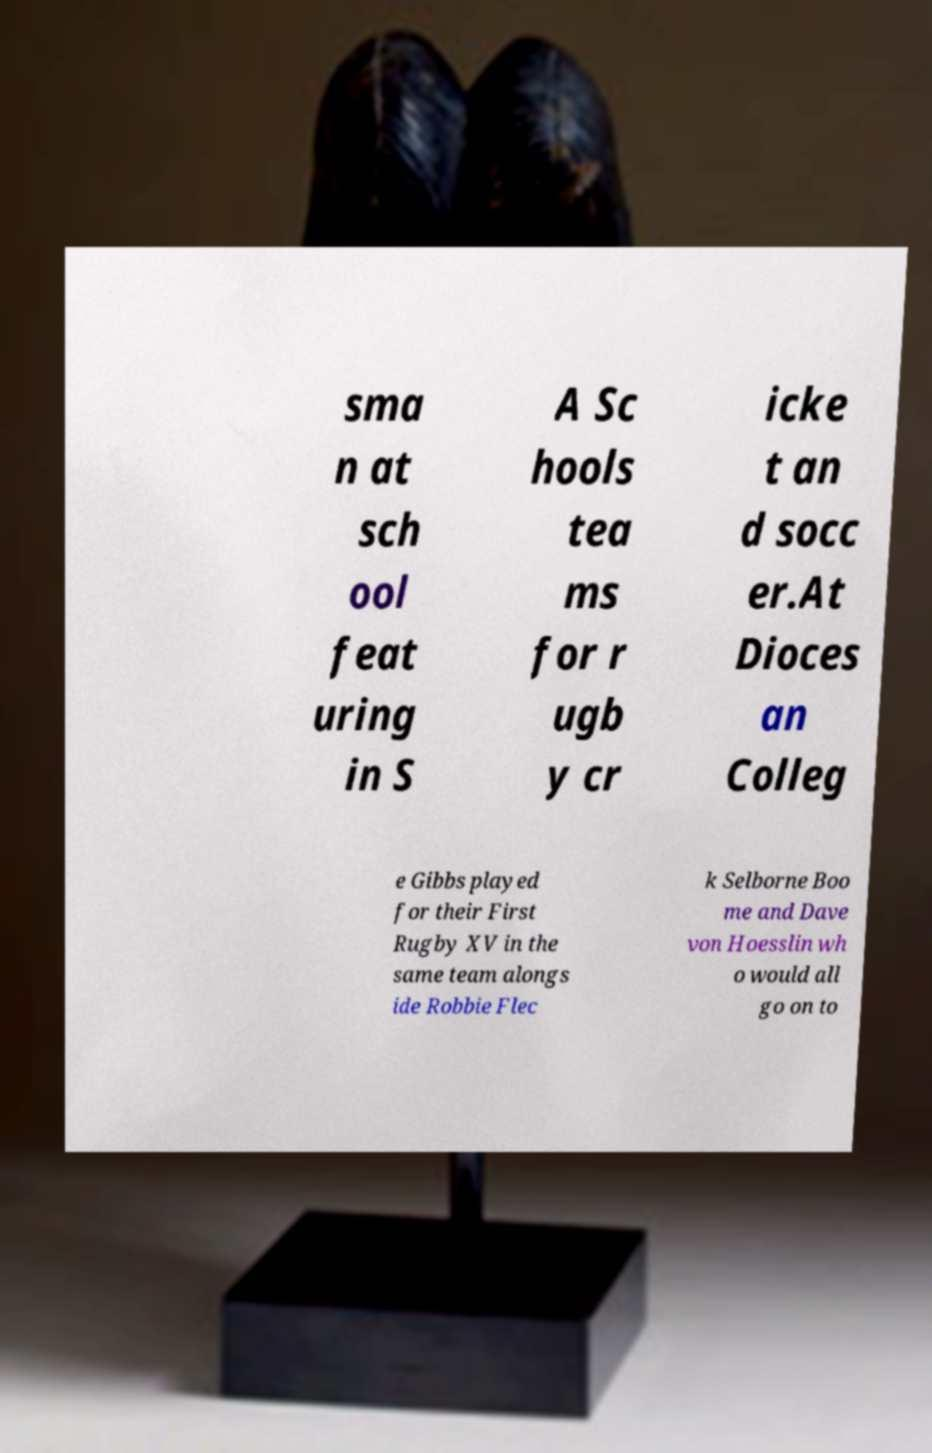Could you assist in decoding the text presented in this image and type it out clearly? sma n at sch ool feat uring in S A Sc hools tea ms for r ugb y cr icke t an d socc er.At Dioces an Colleg e Gibbs played for their First Rugby XV in the same team alongs ide Robbie Flec k Selborne Boo me and Dave von Hoesslin wh o would all go on to 